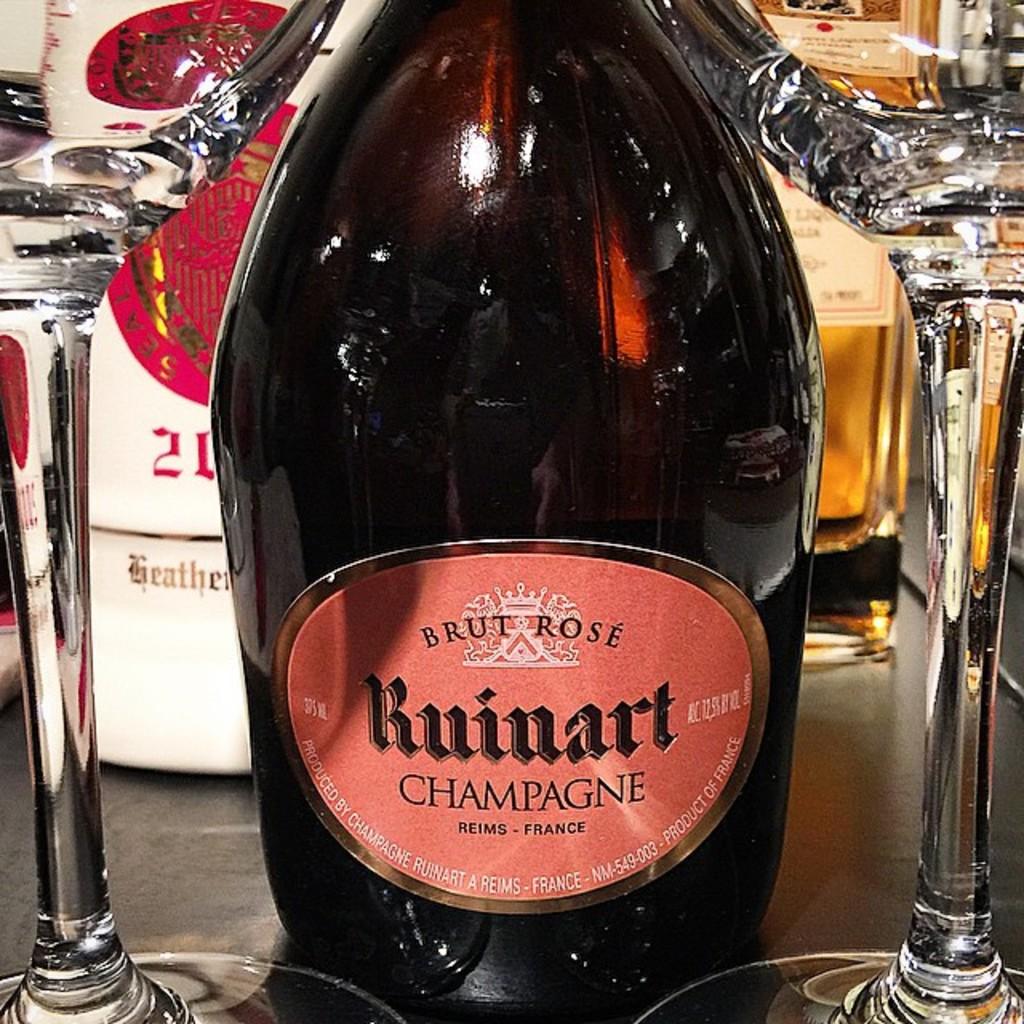Is this from france?
Keep it short and to the point. Yes. 